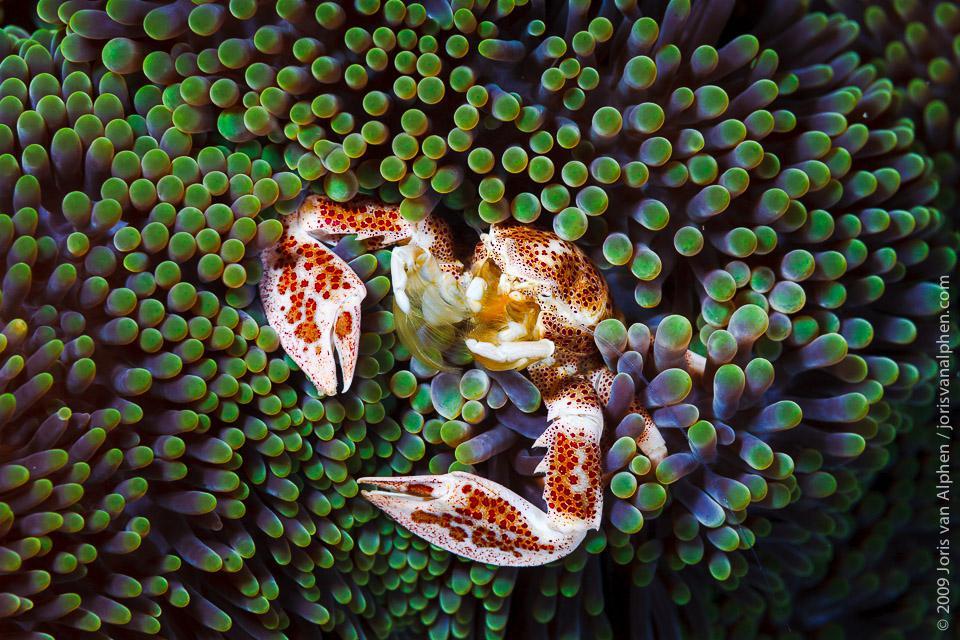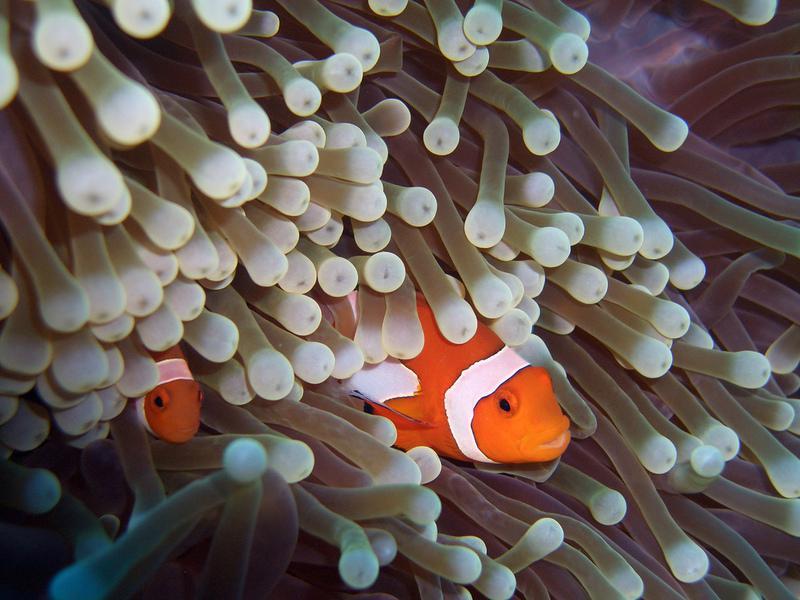The first image is the image on the left, the second image is the image on the right. Assess this claim about the two images: "At least one clown fish is nestled among the sea anemones.". Correct or not? Answer yes or no. Yes. The first image is the image on the left, the second image is the image on the right. Given the left and right images, does the statement "One image shows the reddish-orange tinged front claws of a crustacean emerging from something with green tendrils." hold true? Answer yes or no. Yes. 